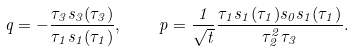Convert formula to latex. <formula><loc_0><loc_0><loc_500><loc_500>q = - \frac { \tau _ { 3 } s _ { 3 } ( \tau _ { 3 } ) } { \tau _ { 1 } s _ { 1 } ( \tau _ { 1 } ) } , \quad p = \frac { 1 } { \sqrt { t } } \frac { \tau _ { 1 } s _ { 1 } ( \tau _ { 1 } ) s _ { 0 } s _ { 1 } ( \tau _ { 1 } ) } { \tau _ { 2 } ^ { 2 } \tau _ { 3 } } .</formula> 